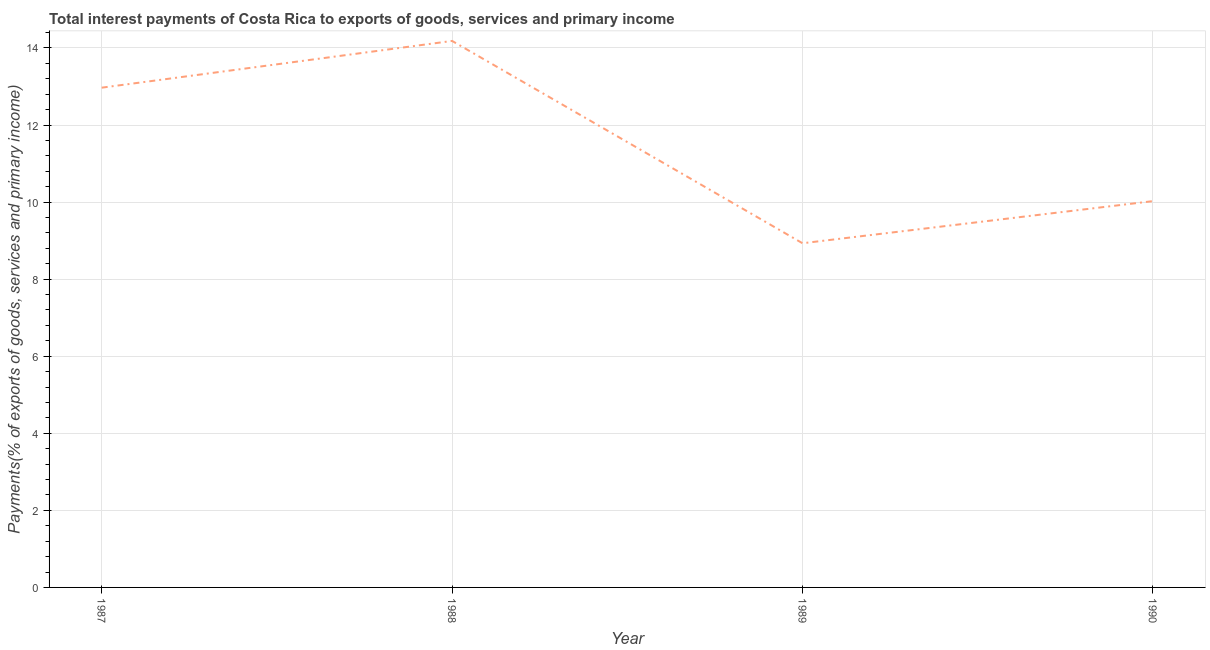What is the total interest payments on external debt in 1990?
Your response must be concise. 10.02. Across all years, what is the maximum total interest payments on external debt?
Your response must be concise. 14.18. Across all years, what is the minimum total interest payments on external debt?
Offer a very short reply. 8.93. In which year was the total interest payments on external debt minimum?
Offer a very short reply. 1989. What is the sum of the total interest payments on external debt?
Your answer should be compact. 46.11. What is the difference between the total interest payments on external debt in 1988 and 1990?
Give a very brief answer. 4.16. What is the average total interest payments on external debt per year?
Offer a very short reply. 11.53. What is the median total interest payments on external debt?
Provide a succinct answer. 11.5. What is the ratio of the total interest payments on external debt in 1987 to that in 1989?
Your answer should be very brief. 1.45. What is the difference between the highest and the second highest total interest payments on external debt?
Your answer should be compact. 1.21. Is the sum of the total interest payments on external debt in 1989 and 1990 greater than the maximum total interest payments on external debt across all years?
Give a very brief answer. Yes. What is the difference between the highest and the lowest total interest payments on external debt?
Provide a succinct answer. 5.25. How many years are there in the graph?
Provide a succinct answer. 4. What is the difference between two consecutive major ticks on the Y-axis?
Provide a succinct answer. 2. Are the values on the major ticks of Y-axis written in scientific E-notation?
Provide a succinct answer. No. Does the graph contain any zero values?
Offer a terse response. No. Does the graph contain grids?
Provide a short and direct response. Yes. What is the title of the graph?
Offer a terse response. Total interest payments of Costa Rica to exports of goods, services and primary income. What is the label or title of the X-axis?
Keep it short and to the point. Year. What is the label or title of the Y-axis?
Make the answer very short. Payments(% of exports of goods, services and primary income). What is the Payments(% of exports of goods, services and primary income) of 1987?
Provide a succinct answer. 12.97. What is the Payments(% of exports of goods, services and primary income) of 1988?
Keep it short and to the point. 14.18. What is the Payments(% of exports of goods, services and primary income) of 1989?
Offer a very short reply. 8.93. What is the Payments(% of exports of goods, services and primary income) of 1990?
Make the answer very short. 10.02. What is the difference between the Payments(% of exports of goods, services and primary income) in 1987 and 1988?
Give a very brief answer. -1.21. What is the difference between the Payments(% of exports of goods, services and primary income) in 1987 and 1989?
Your answer should be very brief. 4.04. What is the difference between the Payments(% of exports of goods, services and primary income) in 1987 and 1990?
Provide a short and direct response. 2.94. What is the difference between the Payments(% of exports of goods, services and primary income) in 1988 and 1989?
Your answer should be very brief. 5.25. What is the difference between the Payments(% of exports of goods, services and primary income) in 1988 and 1990?
Provide a short and direct response. 4.16. What is the difference between the Payments(% of exports of goods, services and primary income) in 1989 and 1990?
Your answer should be compact. -1.09. What is the ratio of the Payments(% of exports of goods, services and primary income) in 1987 to that in 1988?
Make the answer very short. 0.91. What is the ratio of the Payments(% of exports of goods, services and primary income) in 1987 to that in 1989?
Your response must be concise. 1.45. What is the ratio of the Payments(% of exports of goods, services and primary income) in 1987 to that in 1990?
Offer a very short reply. 1.29. What is the ratio of the Payments(% of exports of goods, services and primary income) in 1988 to that in 1989?
Your answer should be very brief. 1.59. What is the ratio of the Payments(% of exports of goods, services and primary income) in 1988 to that in 1990?
Provide a succinct answer. 1.42. What is the ratio of the Payments(% of exports of goods, services and primary income) in 1989 to that in 1990?
Your answer should be compact. 0.89. 